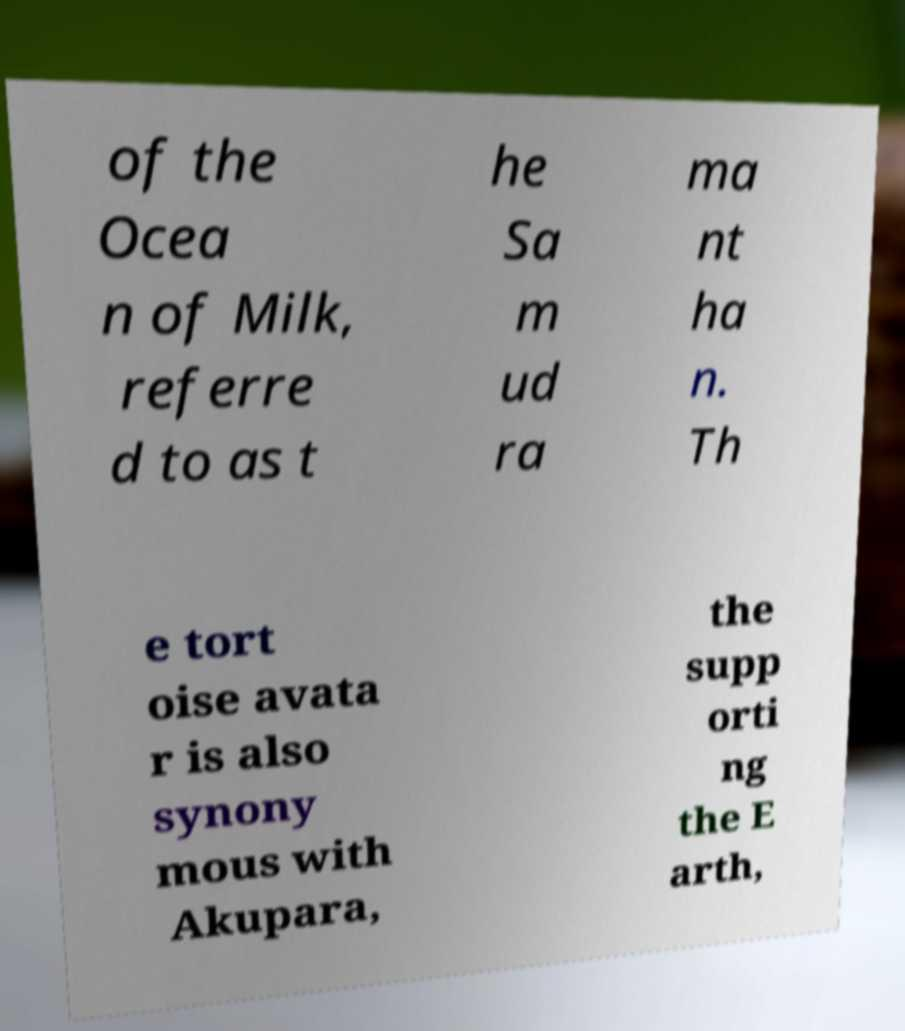Please identify and transcribe the text found in this image. of the Ocea n of Milk, referre d to as t he Sa m ud ra ma nt ha n. Th e tort oise avata r is also synony mous with Akupara, the supp orti ng the E arth, 